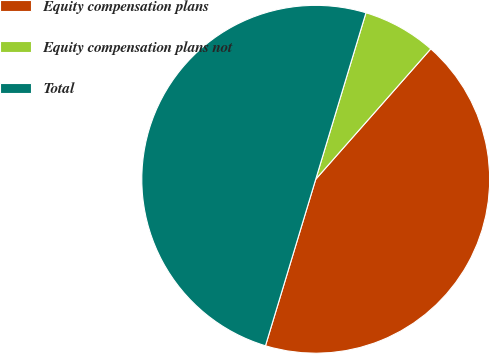<chart> <loc_0><loc_0><loc_500><loc_500><pie_chart><fcel>Equity compensation plans<fcel>Equity compensation plans not<fcel>Total<nl><fcel>43.16%<fcel>6.84%<fcel>50.0%<nl></chart> 